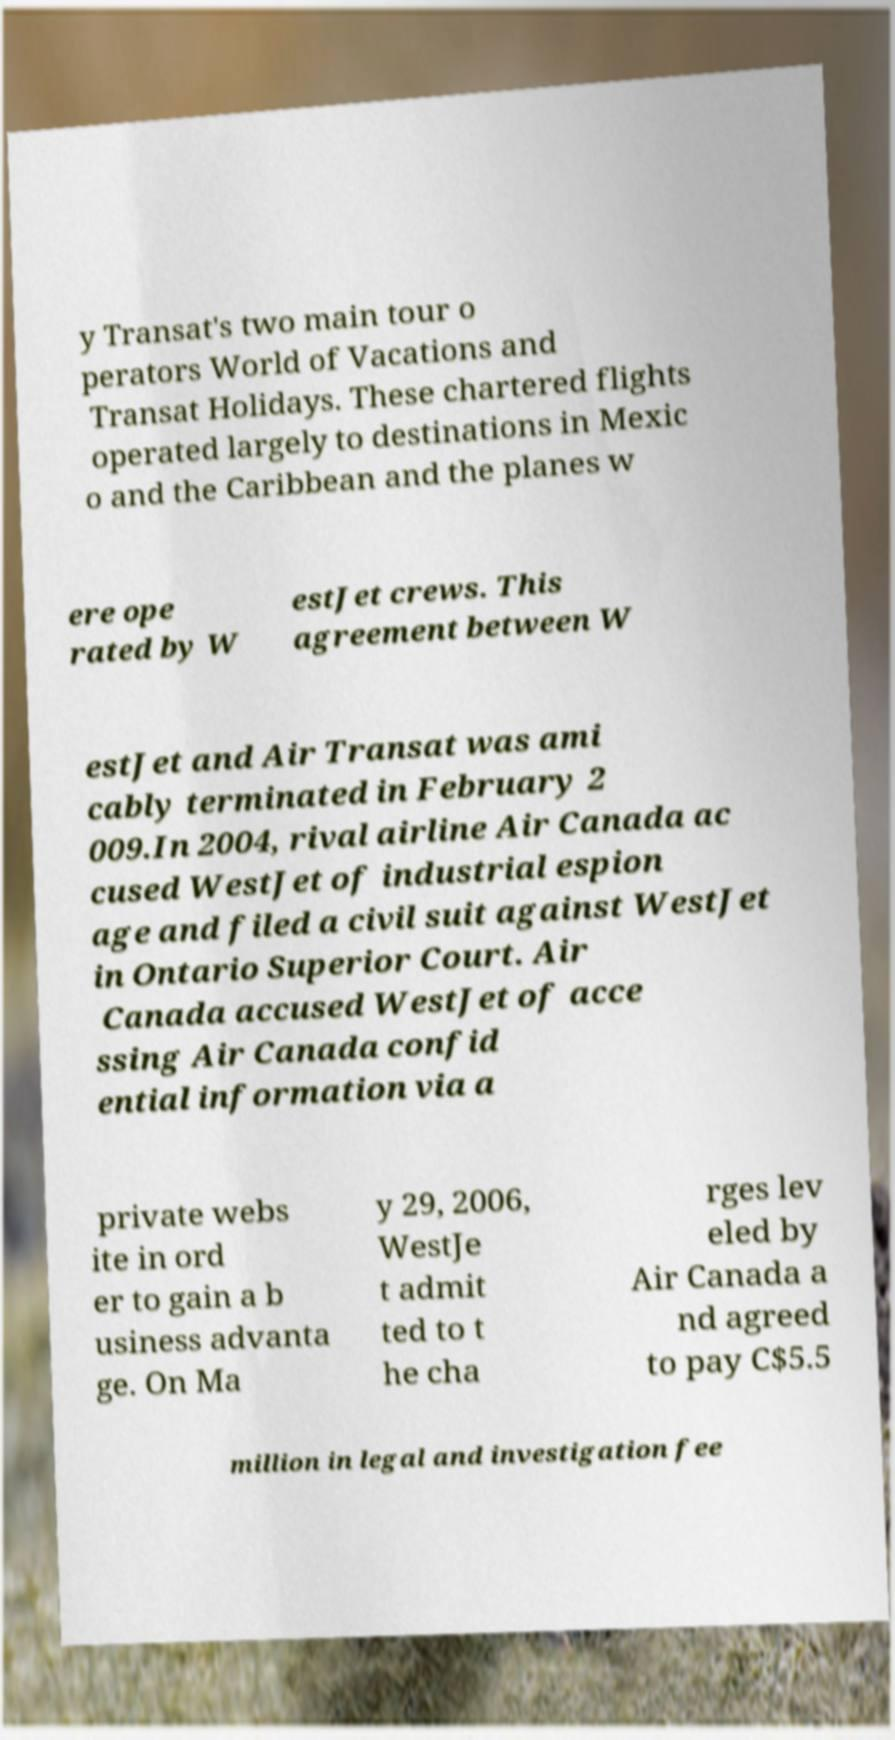Can you read and provide the text displayed in the image?This photo seems to have some interesting text. Can you extract and type it out for me? y Transat's two main tour o perators World of Vacations and Transat Holidays. These chartered flights operated largely to destinations in Mexic o and the Caribbean and the planes w ere ope rated by W estJet crews. This agreement between W estJet and Air Transat was ami cably terminated in February 2 009.In 2004, rival airline Air Canada ac cused WestJet of industrial espion age and filed a civil suit against WestJet in Ontario Superior Court. Air Canada accused WestJet of acce ssing Air Canada confid ential information via a private webs ite in ord er to gain a b usiness advanta ge. On Ma y 29, 2006, WestJe t admit ted to t he cha rges lev eled by Air Canada a nd agreed to pay C$5.5 million in legal and investigation fee 